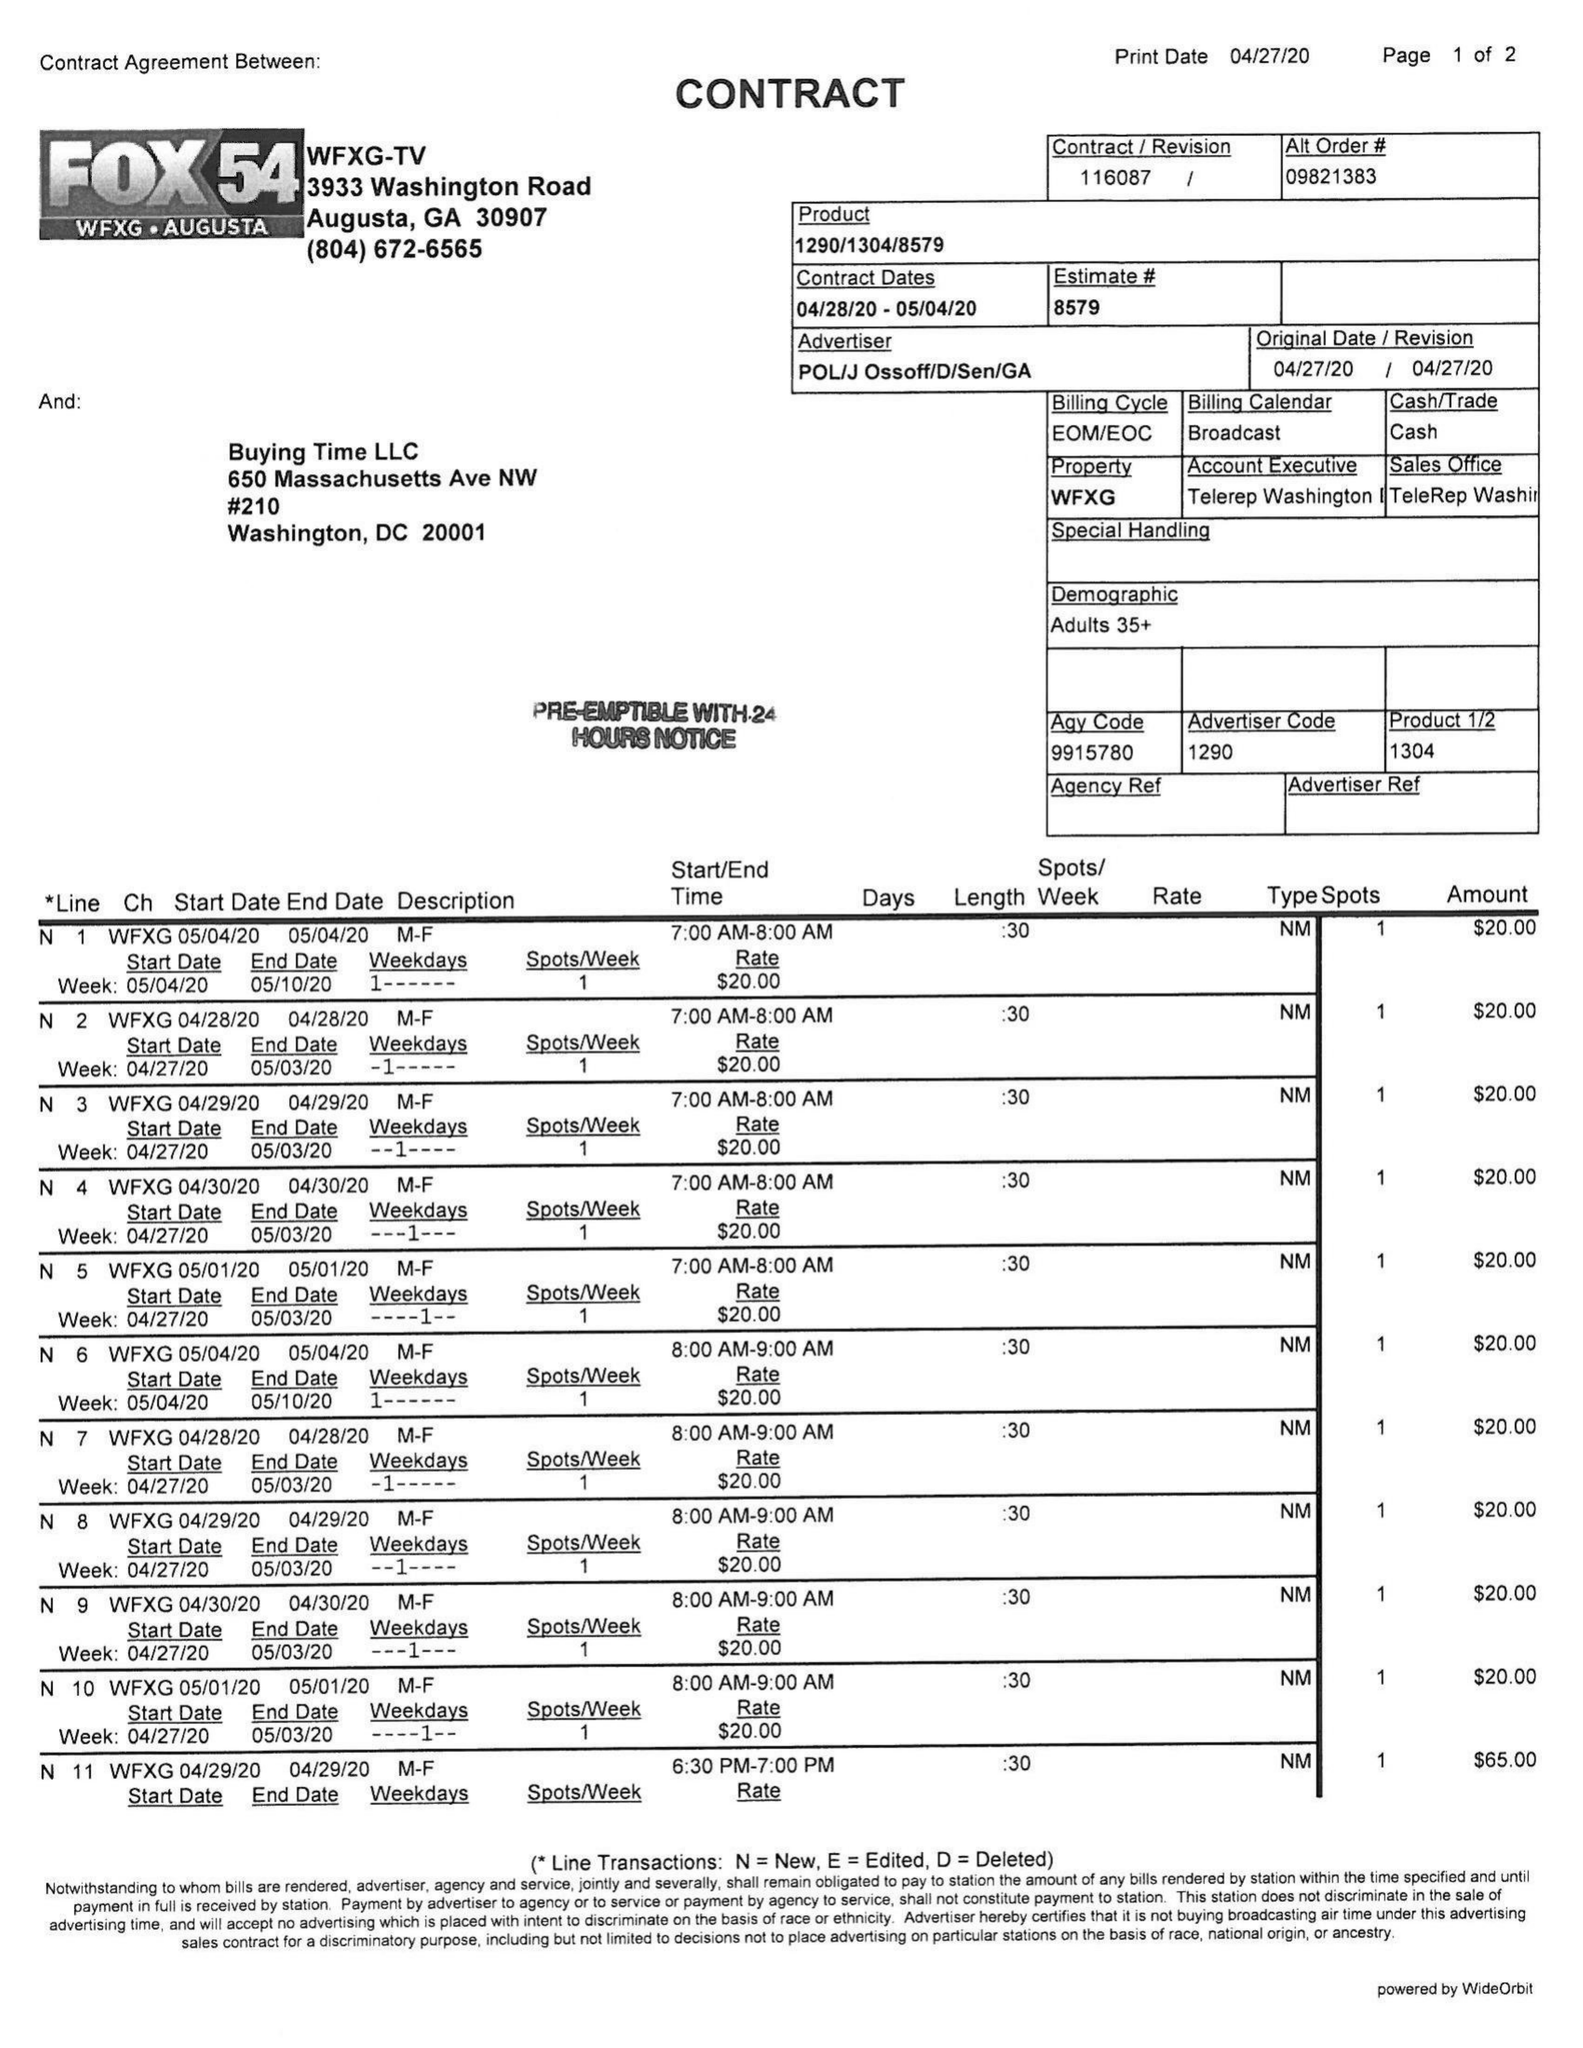What is the value for the flight_from?
Answer the question using a single word or phrase. 04/28/20 